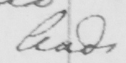Can you read and transcribe this handwriting? leads 